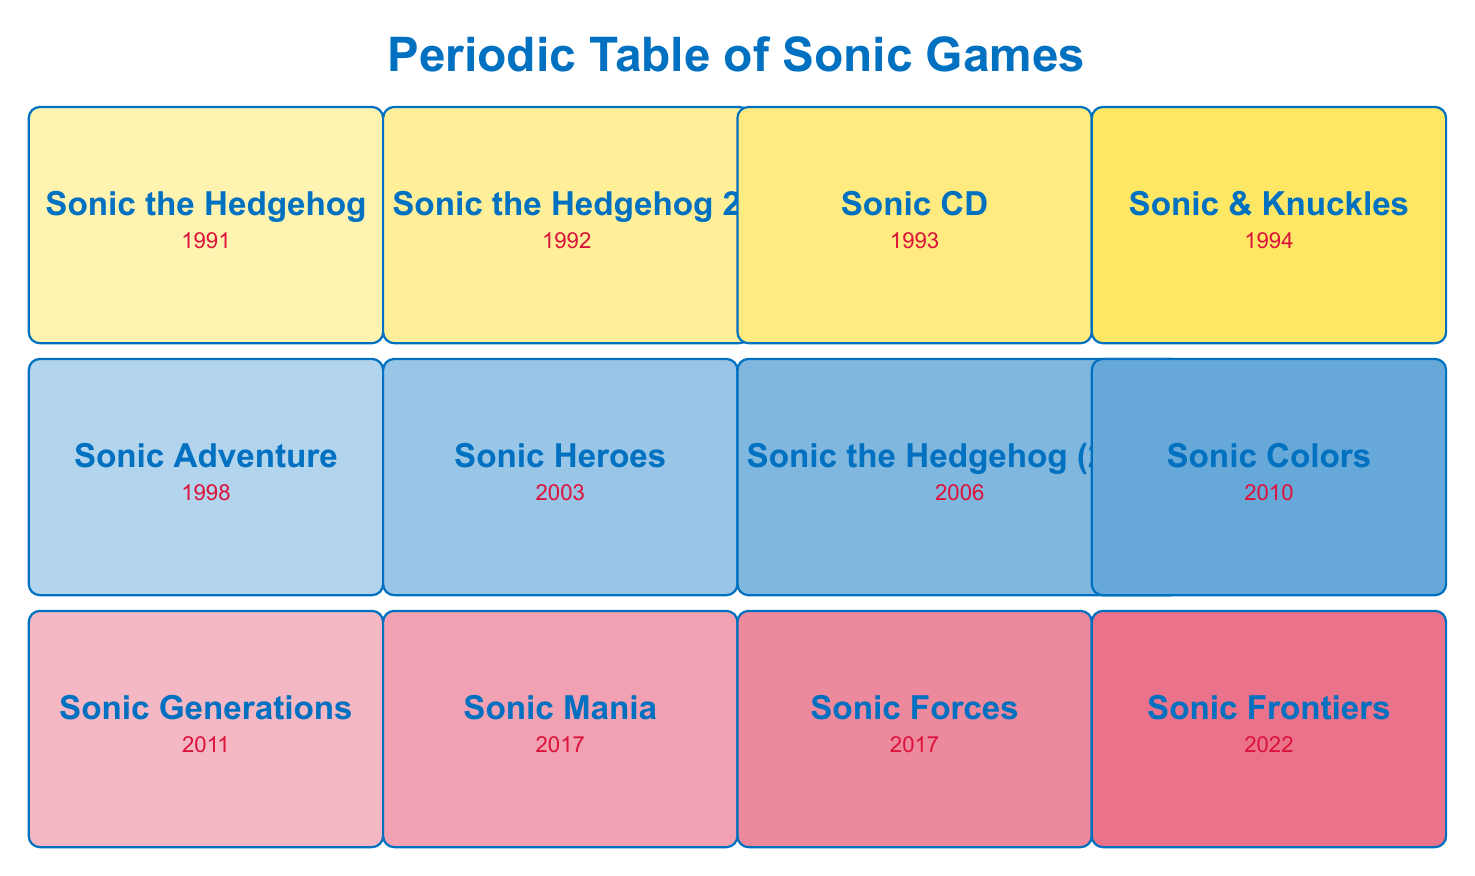What year was Sonic Colors released? Sonic Colors is listed in the table next to the year 2010.
Answer: 2010 Which game was released in 1994? Looking at the table, Sonic & Knuckles is the only game listed under the year 1994.
Answer: Sonic & Knuckles What is the total number of Sonic games released from 1991 to 2010? There are 7 games listed in the table from 1991 to 2010: Sonic the Hedgehog, Sonic the Hedgehog 2, Sonic CD, Sonic & Knuckles, Sonic Adventure, Sonic Heroes, and Sonic Colors.
Answer: 7 Is Sonic Adventure the only game released in 1998? From the table, Sonic Adventure is the only game listed for the year 1998, confirming the statement is true.
Answer: Yes Which two games share the same release year of 2017? In the table, both Sonic Mania and Sonic Forces are listed under the year 2017, indicating they were released in the same year.
Answer: Sonic Mania, Sonic Forces What is the average release year of the listed Sonic games? The years for the games are: 1991, 1992, 1993, 1994, 1998, 2003, 2006, 2010, 2011, 2017, 2017, and 2022. Adding these years gives 1991 + 1992 + 1993 + 1994 + 1998 + 2003 + 2006 + 2010 + 2011 + 2017 + 2017 + 2022 = 23958. Dividing by the number of games (12) yields an average year of 1996.5.
Answer: 1996.5 Which game has the genre "3D Platform" but was not released on a Sega console? Looking at the table, Sonic Heroes is listed under the genre "3D Platform" and is classified as a Multi-Platform game, which confirms it was not exclusive to a Sega console.
Answer: Sonic Heroes Is Sonic Frontiers the latest game listed in the table? Sonic Frontiers is the only game with the release year 2022, and since it is the most recent year in the table, the statement is true.
Answer: Yes 